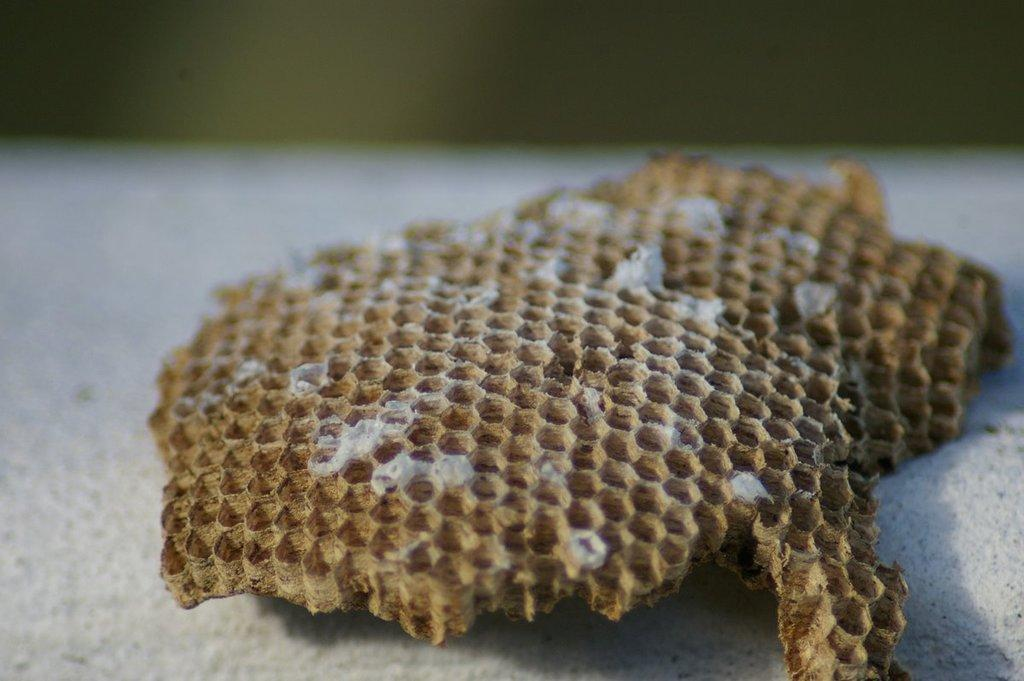What is present in the sand in the image? There is a dried honey bee wax in the sand. What type of songs are the rabbits singing in the image? There are no rabbits or songs present in the image; it features a dried honey bee wax in the sand. 